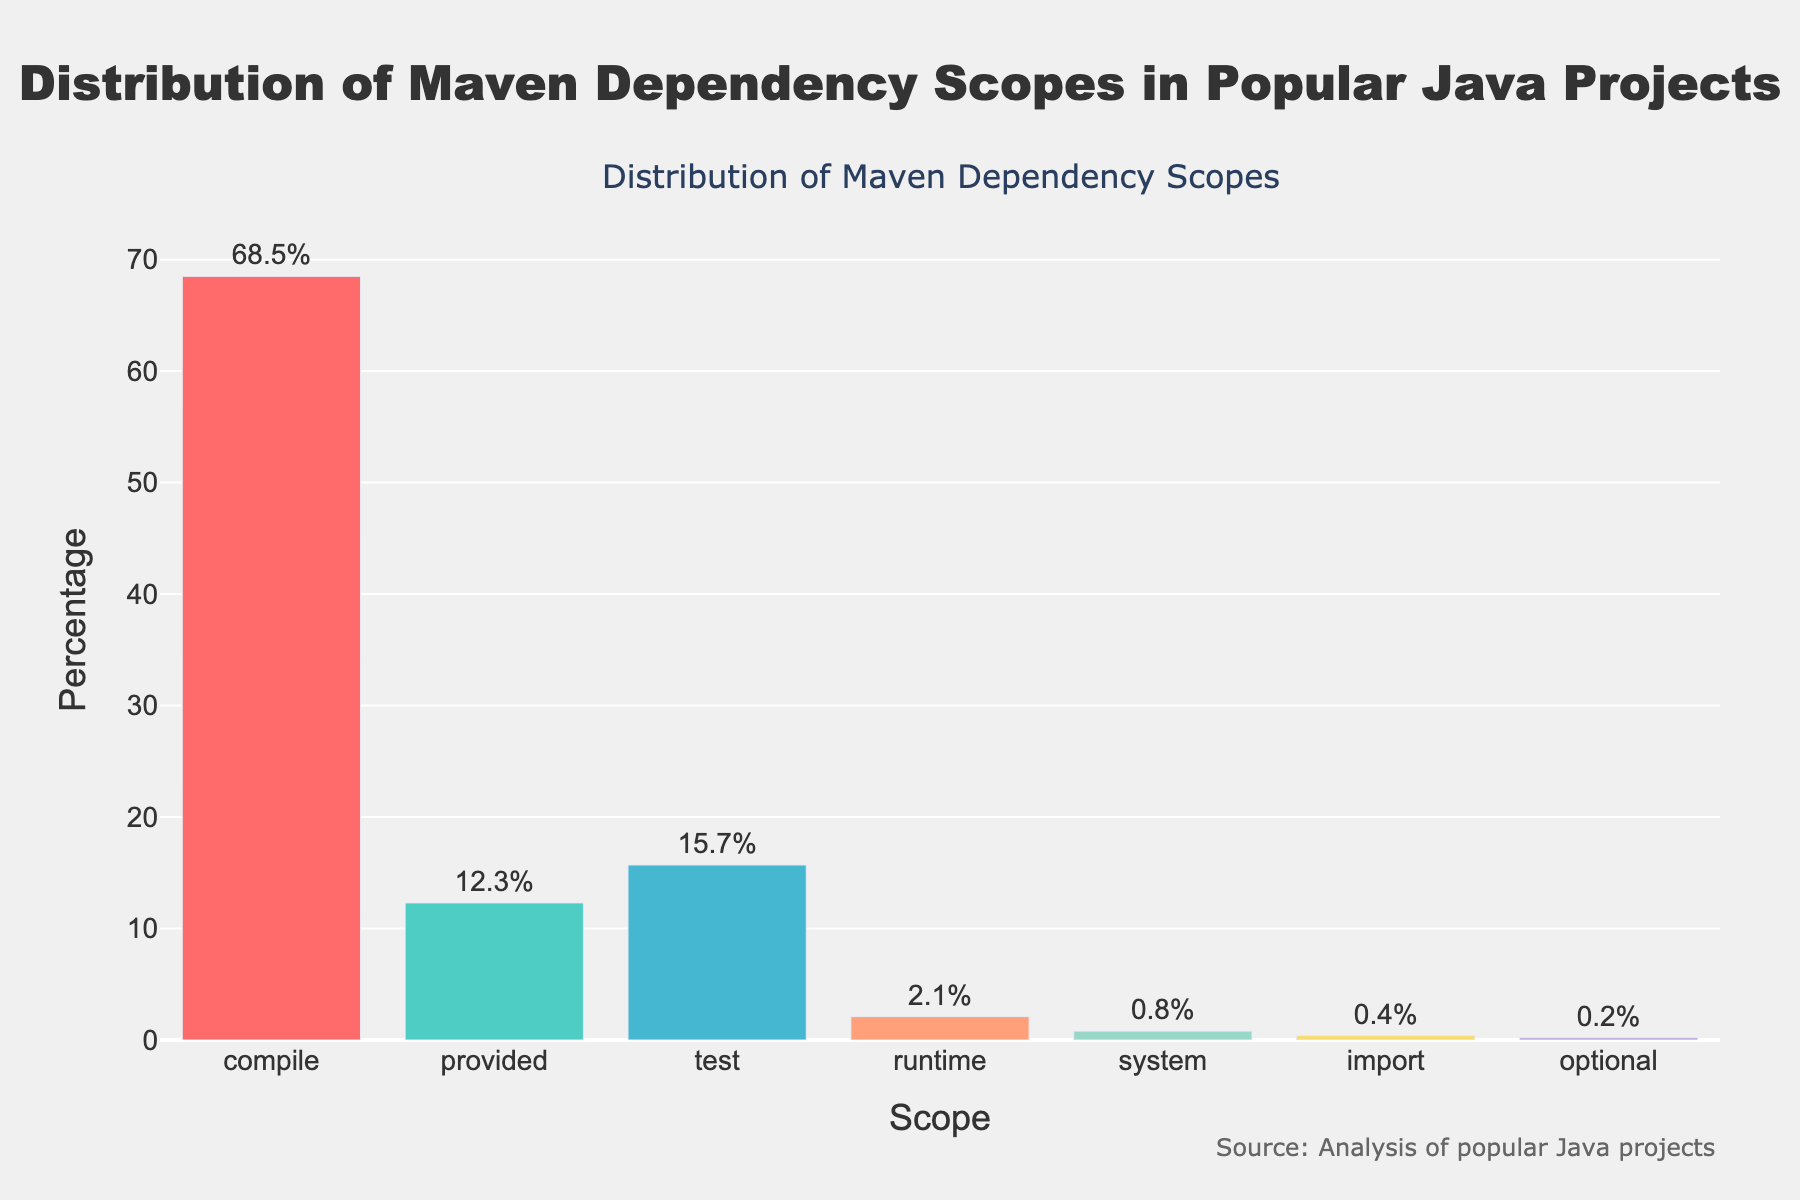Which Maven dependency scope has the highest percentage? Look at the bar chart and identify the tallest bar. The tallest bar corresponds to the "compile" scope with a height representing 68.5%.
Answer: compile Which two Maven dependency scopes have the smallest percentages combined? Find the two shortest bars in the chart, which are "optional" (0.2%) and "import" (0.4%). Add their percentages: 0.2% + 0.4% = 0.6%.
Answer: optional and import What is the difference in percentage between the 'test' scope and the 'provided' scope? Identify the percentages for 'test' (15.7%) and 'provided' (12.3%). Subtract the smaller percentage from the larger: 15.7% - 12.3% = 3.4%.
Answer: 3.4% Which Maven dependency scope has a percentage closest to 15%? Identify the bar with a percentage closest to 15%. The 'test' scope has 15.7%, which is closest to 15%.
Answer: test What is the total percentage for all Maven dependency scopes other than 'compile'? Sum the percentages of all scopes except 'compile': 12.3% (provided) + 15.7% (test) + 2.1% (runtime) + 0.8% (system) + 0.4% (import) + 0.2% (optional) = 31.5%.
Answer: 31.5% Which Maven dependency scope has the second highest percentage and what is it? Look at the bar chart and identify the second tallest bar after 'compile'. The 'test' scope is the second tallest with 15.7%.
Answer: test, 15.7% Is the percentage of 'runtime' scope greater than 2%? Check the percentage for 'runtime' scope in the chart. It is 2.1%, which is greater than 2%.
Answer: Yes How many Maven dependency scopes have a percentage lower than 1%? Count the number of bars with percentages lower than 1% from the chart. They are 'system' (0.8%), 'import' (0.4%), and 'optional' (0.2%), which totals three.
Answer: 3 Which two Maven dependency scopes, when combined, make up more than 80% of the total? Identify the highest percentage scopes: 'compile' (68.5%) and 'test' (15.7%). Add their percentages: 68.5% + 15.7% = 84.2%, which is more than 80%.
Answer: compile and test 